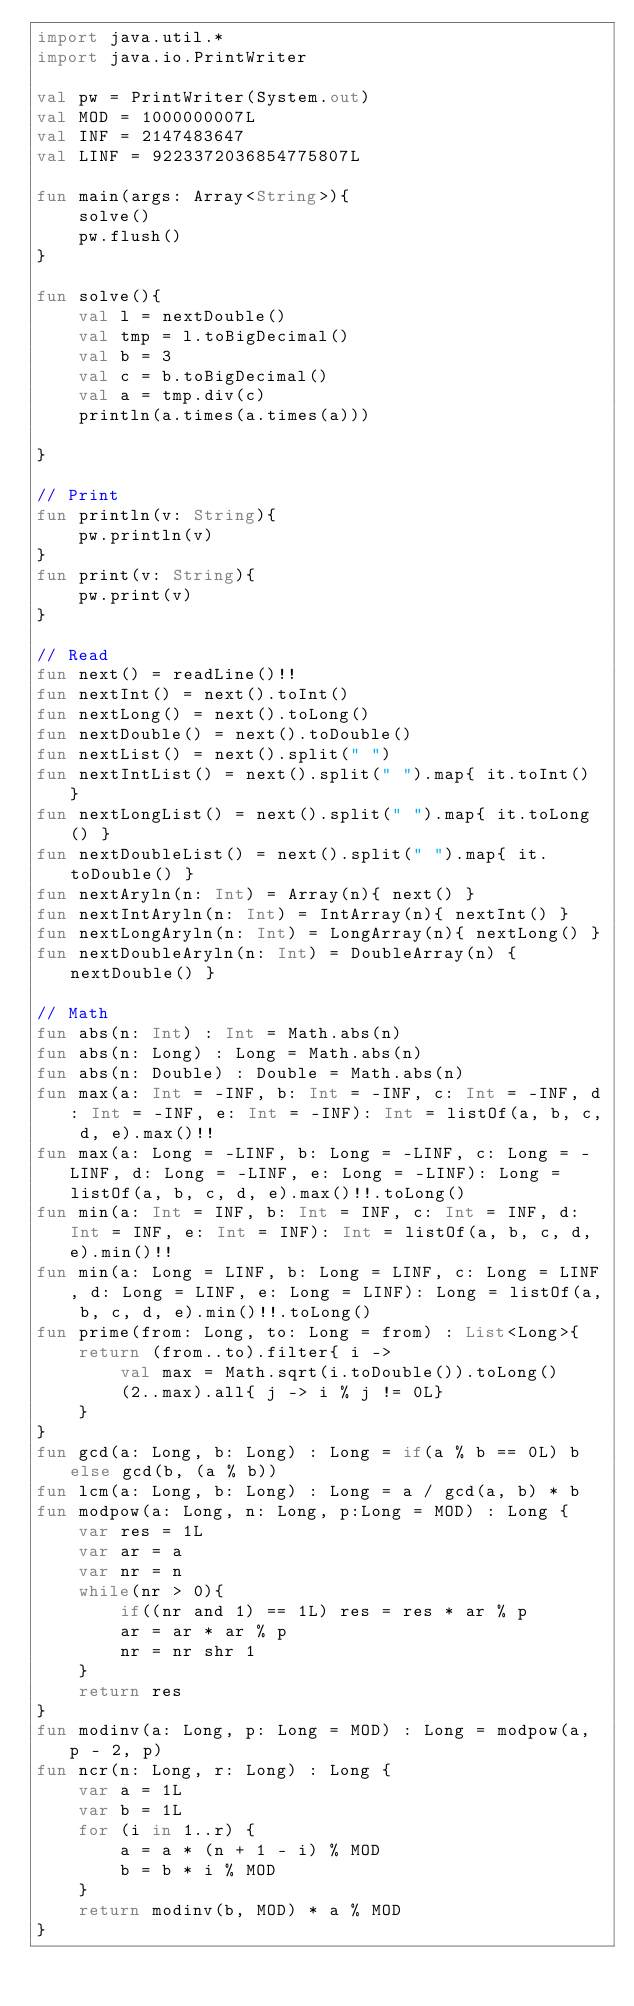Convert code to text. <code><loc_0><loc_0><loc_500><loc_500><_Kotlin_>import java.util.*
import java.io.PrintWriter

val pw = PrintWriter(System.out)
val MOD = 1000000007L
val INF = 2147483647
val LINF = 9223372036854775807L

fun main(args: Array<String>){
    solve()
    pw.flush()    
}

fun solve(){
    val l = nextDouble()
    val tmp = l.toBigDecimal()
    val b = 3
    val c = b.toBigDecimal()
    val a = tmp.div(c)
    println(a.times(a.times(a)))

}

// Print
fun println(v: String){
    pw.println(v)
}
fun print(v: String){
    pw.print(v)
}

// Read
fun next() = readLine()!!
fun nextInt() = next().toInt()
fun nextLong() = next().toLong()
fun nextDouble() = next().toDouble()
fun nextList() = next().split(" ")
fun nextIntList() = next().split(" ").map{ it.toInt() }
fun nextLongList() = next().split(" ").map{ it.toLong() }
fun nextDoubleList() = next().split(" ").map{ it.toDouble() }
fun nextAryln(n: Int) = Array(n){ next() }
fun nextIntAryln(n: Int) = IntArray(n){ nextInt() }
fun nextLongAryln(n: Int) = LongArray(n){ nextLong() }
fun nextDoubleAryln(n: Int) = DoubleArray(n) { nextDouble() }

// Math
fun abs(n: Int) : Int = Math.abs(n)
fun abs(n: Long) : Long = Math.abs(n)
fun abs(n: Double) : Double = Math.abs(n)
fun max(a: Int = -INF, b: Int = -INF, c: Int = -INF, d: Int = -INF, e: Int = -INF): Int = listOf(a, b, c, d, e).max()!!
fun max(a: Long = -LINF, b: Long = -LINF, c: Long = -LINF, d: Long = -LINF, e: Long = -LINF): Long = listOf(a, b, c, d, e).max()!!.toLong()
fun min(a: Int = INF, b: Int = INF, c: Int = INF, d: Int = INF, e: Int = INF): Int = listOf(a, b, c, d, e).min()!!
fun min(a: Long = LINF, b: Long = LINF, c: Long = LINF, d: Long = LINF, e: Long = LINF): Long = listOf(a, b, c, d, e).min()!!.toLong()
fun prime(from: Long, to: Long = from) : List<Long>{
    return (from..to).filter{ i ->
        val max = Math.sqrt(i.toDouble()).toLong()
        (2..max).all{ j -> i % j != 0L}
    }
}
fun gcd(a: Long, b: Long) : Long = if(a % b == 0L) b else gcd(b, (a % b))
fun lcm(a: Long, b: Long) : Long = a / gcd(a, b) * b
fun modpow(a: Long, n: Long, p:Long = MOD) : Long {
    var res = 1L
    var ar = a
    var nr = n
    while(nr > 0){
        if((nr and 1) == 1L) res = res * ar % p
        ar = ar * ar % p
        nr = nr shr 1
    }
    return res
}
fun modinv(a: Long, p: Long = MOD) : Long = modpow(a, p - 2, p)
fun ncr(n: Long, r: Long) : Long {
    var a = 1L
    var b = 1L
    for (i in 1..r) {
        a = a * (n + 1 - i) % MOD
        b = b * i % MOD
    }
    return modinv(b, MOD) * a % MOD
}
</code> 